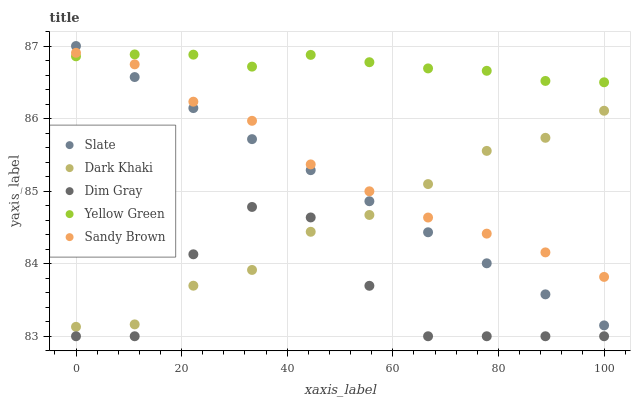Does Dim Gray have the minimum area under the curve?
Answer yes or no. Yes. Does Yellow Green have the maximum area under the curve?
Answer yes or no. Yes. Does Slate have the minimum area under the curve?
Answer yes or no. No. Does Slate have the maximum area under the curve?
Answer yes or no. No. Is Slate the smoothest?
Answer yes or no. Yes. Is Dim Gray the roughest?
Answer yes or no. Yes. Is Dim Gray the smoothest?
Answer yes or no. No. Is Slate the roughest?
Answer yes or no. No. Does Dim Gray have the lowest value?
Answer yes or no. Yes. Does Slate have the lowest value?
Answer yes or no. No. Does Slate have the highest value?
Answer yes or no. Yes. Does Dim Gray have the highest value?
Answer yes or no. No. Is Dark Khaki less than Yellow Green?
Answer yes or no. Yes. Is Sandy Brown greater than Dim Gray?
Answer yes or no. Yes. Does Slate intersect Sandy Brown?
Answer yes or no. Yes. Is Slate less than Sandy Brown?
Answer yes or no. No. Is Slate greater than Sandy Brown?
Answer yes or no. No. Does Dark Khaki intersect Yellow Green?
Answer yes or no. No. 